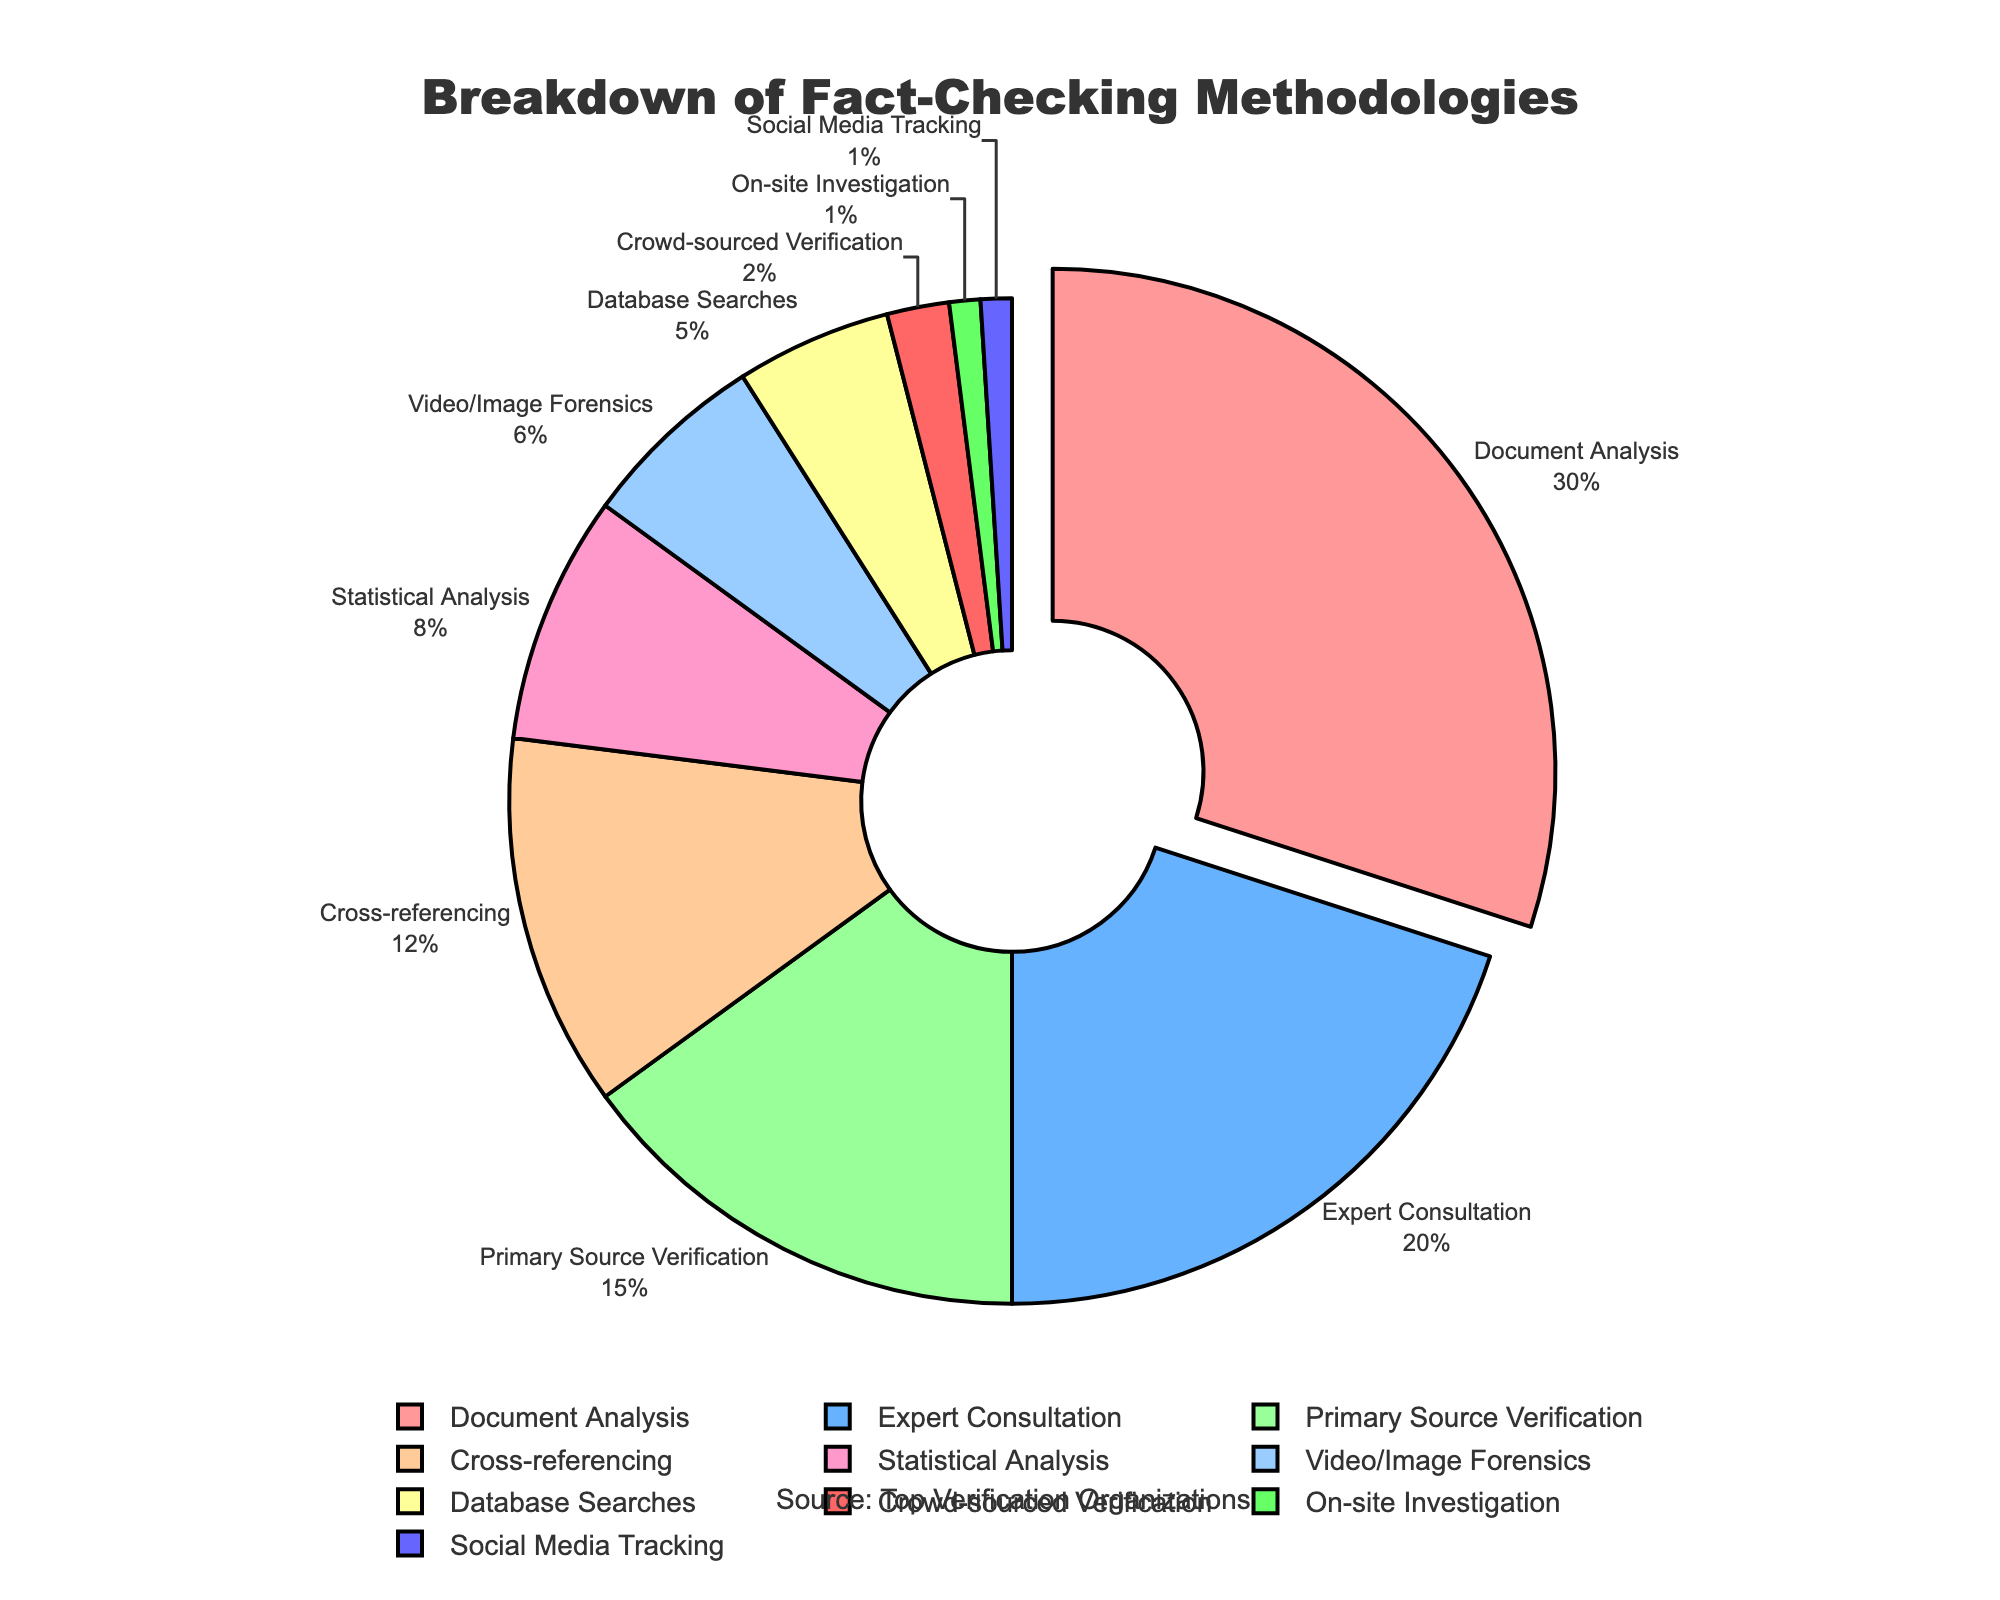What percentage of fact-checking methodologies is attributed to Document Analysis? Document Analysis has a percentage of 30% as shown on the pie chart.
Answer: 30% Which methodology takes up the smallest portion of the pie chart? The methodology that takes up the smallest portion of the pie chart is Social Media Tracking and On-site Investigation, both at 1%.
Answer: Social Media Tracking and On-site Investigation What is the combined percentage of Expert Consultation and Primary Source Verification? Expert Consultation has 20% and Primary Source Verification has 15%. Combined, they total 20% + 15% = 35%.
Answer: 35% How many methodologies have a percentage less than 10%? From the chart, there are six methodologies with percentages less than 10%: Statistical Analysis (8%), Video/Image Forensics (6%), Database Searches (5%), Crowd-sourced Verification (2%), On-site Investigation (1%), and Social Media Tracking (1%).
Answer: 6 Which methodology is represented by the largest slice of the pie chart? The largest slice of the pie chart represents Document Analysis which accounts for 30%.
Answer: Document Analysis By how much does the percentage of Document Analysis exceed the percentage of Expert Consultation? Document Analysis is at 30% and Expert Consultation is at 20%. The difference is 30% - 20% = 10%.
Answer: 10% What is the combined percentage of all methodologies related to direct source verification (Primary Source Verification and Database Searches)? Primary Source Verification is at 15% and Database Searches are at 5%. The combined percentage is 15% + 5% = 20%.
Answer: 20% Which methodology is represented by the blue slice, and what is its percentage? The blue slice represents Expert Consultation with a percentage of 20%.
Answer: Expert Consultation, 20% Compare the percentage of Cross-referencing and Statistical Analysis; which has a higher value and by how much? Cross-referencing has a percentage of 12%, while Statistical Analysis is at 8%. Cross-referencing exceeds Statistical Analysis by 12% - 8% = 4%.
Answer: Cross-referencing, 4% If you combine the smallest four methodologies, what is their total percentage? The smallest four methodologies are Crowd-sourced Verification, On-site Investigation, Social Media Tracking, and Database Searches with percentages 2%, 1%, 1%, and 5% respectively. Their total is 2% + 1% + 1% + 5% = 9%.
Answer: 9% 